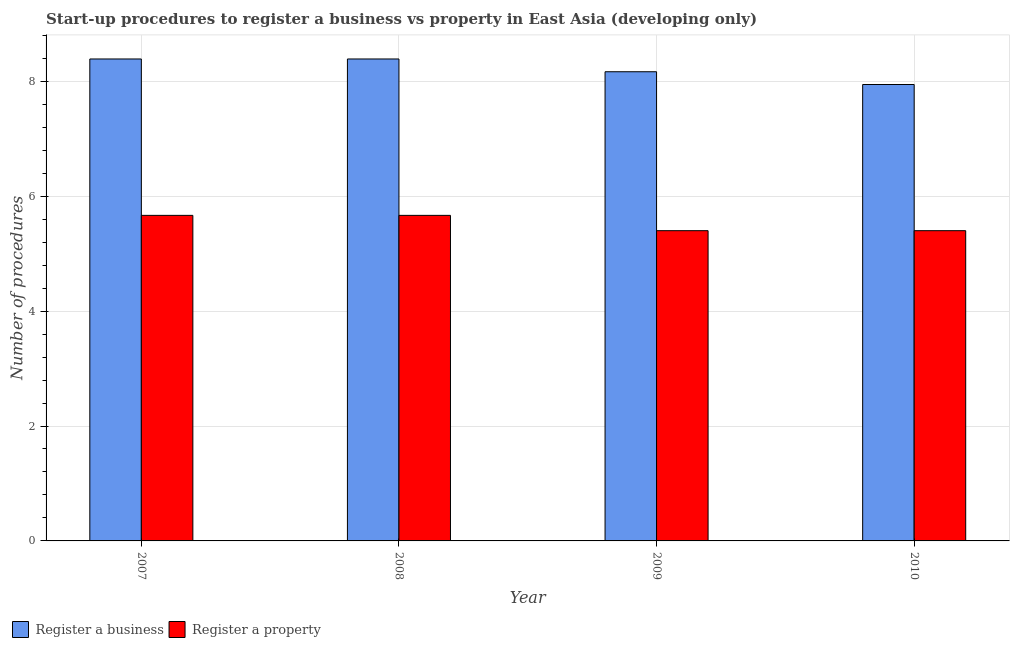How many groups of bars are there?
Your answer should be compact. 4. Are the number of bars per tick equal to the number of legend labels?
Ensure brevity in your answer.  Yes. What is the label of the 3rd group of bars from the left?
Your response must be concise. 2009. What is the number of procedures to register a business in 2008?
Your answer should be very brief. 8.39. Across all years, what is the maximum number of procedures to register a property?
Keep it short and to the point. 5.67. Across all years, what is the minimum number of procedures to register a property?
Make the answer very short. 5.4. In which year was the number of procedures to register a property maximum?
Your response must be concise. 2007. What is the total number of procedures to register a property in the graph?
Give a very brief answer. 22.13. What is the difference between the number of procedures to register a property in 2008 and that in 2010?
Ensure brevity in your answer.  0.27. What is the difference between the number of procedures to register a property in 2010 and the number of procedures to register a business in 2007?
Make the answer very short. -0.27. What is the average number of procedures to register a property per year?
Offer a terse response. 5.53. In the year 2009, what is the difference between the number of procedures to register a property and number of procedures to register a business?
Offer a very short reply. 0. In how many years, is the number of procedures to register a business greater than 0.4?
Give a very brief answer. 4. What is the ratio of the number of procedures to register a business in 2008 to that in 2009?
Offer a terse response. 1.03. What is the difference between the highest and the lowest number of procedures to register a property?
Offer a very short reply. 0.27. What does the 1st bar from the left in 2008 represents?
Offer a very short reply. Register a business. What does the 1st bar from the right in 2009 represents?
Your response must be concise. Register a property. How many bars are there?
Offer a terse response. 8. How many years are there in the graph?
Provide a succinct answer. 4. Does the graph contain any zero values?
Give a very brief answer. No. Does the graph contain grids?
Offer a terse response. Yes. Where does the legend appear in the graph?
Make the answer very short. Bottom left. How many legend labels are there?
Give a very brief answer. 2. What is the title of the graph?
Your answer should be compact. Start-up procedures to register a business vs property in East Asia (developing only). Does "Quality of trade" appear as one of the legend labels in the graph?
Keep it short and to the point. No. What is the label or title of the Y-axis?
Your answer should be compact. Number of procedures. What is the Number of procedures in Register a business in 2007?
Keep it short and to the point. 8.39. What is the Number of procedures in Register a property in 2007?
Keep it short and to the point. 5.67. What is the Number of procedures of Register a business in 2008?
Your answer should be compact. 8.39. What is the Number of procedures in Register a property in 2008?
Your response must be concise. 5.67. What is the Number of procedures in Register a business in 2009?
Keep it short and to the point. 8.17. What is the Number of procedures in Register a property in 2009?
Provide a short and direct response. 5.4. What is the Number of procedures of Register a business in 2010?
Offer a terse response. 7.94. Across all years, what is the maximum Number of procedures in Register a business?
Your answer should be very brief. 8.39. Across all years, what is the maximum Number of procedures in Register a property?
Your answer should be very brief. 5.67. Across all years, what is the minimum Number of procedures in Register a business?
Provide a short and direct response. 7.94. What is the total Number of procedures in Register a business in the graph?
Your answer should be compact. 32.89. What is the total Number of procedures in Register a property in the graph?
Offer a very short reply. 22.13. What is the difference between the Number of procedures of Register a business in 2007 and that in 2008?
Give a very brief answer. 0. What is the difference between the Number of procedures of Register a business in 2007 and that in 2009?
Give a very brief answer. 0.22. What is the difference between the Number of procedures in Register a property in 2007 and that in 2009?
Ensure brevity in your answer.  0.27. What is the difference between the Number of procedures in Register a business in 2007 and that in 2010?
Give a very brief answer. 0.44. What is the difference between the Number of procedures of Register a property in 2007 and that in 2010?
Ensure brevity in your answer.  0.27. What is the difference between the Number of procedures in Register a business in 2008 and that in 2009?
Provide a succinct answer. 0.22. What is the difference between the Number of procedures of Register a property in 2008 and that in 2009?
Keep it short and to the point. 0.27. What is the difference between the Number of procedures in Register a business in 2008 and that in 2010?
Provide a succinct answer. 0.44. What is the difference between the Number of procedures of Register a property in 2008 and that in 2010?
Offer a very short reply. 0.27. What is the difference between the Number of procedures in Register a business in 2009 and that in 2010?
Give a very brief answer. 0.22. What is the difference between the Number of procedures in Register a property in 2009 and that in 2010?
Make the answer very short. 0. What is the difference between the Number of procedures of Register a business in 2007 and the Number of procedures of Register a property in 2008?
Your answer should be compact. 2.72. What is the difference between the Number of procedures in Register a business in 2007 and the Number of procedures in Register a property in 2009?
Offer a very short reply. 2.99. What is the difference between the Number of procedures in Register a business in 2007 and the Number of procedures in Register a property in 2010?
Your answer should be compact. 2.99. What is the difference between the Number of procedures of Register a business in 2008 and the Number of procedures of Register a property in 2009?
Make the answer very short. 2.99. What is the difference between the Number of procedures in Register a business in 2008 and the Number of procedures in Register a property in 2010?
Give a very brief answer. 2.99. What is the difference between the Number of procedures of Register a business in 2009 and the Number of procedures of Register a property in 2010?
Keep it short and to the point. 2.77. What is the average Number of procedures of Register a business per year?
Offer a very short reply. 8.22. What is the average Number of procedures of Register a property per year?
Your answer should be very brief. 5.53. In the year 2007, what is the difference between the Number of procedures in Register a business and Number of procedures in Register a property?
Your response must be concise. 2.72. In the year 2008, what is the difference between the Number of procedures of Register a business and Number of procedures of Register a property?
Your answer should be compact. 2.72. In the year 2009, what is the difference between the Number of procedures in Register a business and Number of procedures in Register a property?
Your response must be concise. 2.77. In the year 2010, what is the difference between the Number of procedures of Register a business and Number of procedures of Register a property?
Give a very brief answer. 2.54. What is the ratio of the Number of procedures in Register a business in 2007 to that in 2009?
Your answer should be compact. 1.03. What is the ratio of the Number of procedures of Register a property in 2007 to that in 2009?
Make the answer very short. 1.05. What is the ratio of the Number of procedures of Register a business in 2007 to that in 2010?
Provide a short and direct response. 1.06. What is the ratio of the Number of procedures of Register a property in 2007 to that in 2010?
Keep it short and to the point. 1.05. What is the ratio of the Number of procedures in Register a business in 2008 to that in 2009?
Ensure brevity in your answer.  1.03. What is the ratio of the Number of procedures in Register a property in 2008 to that in 2009?
Your answer should be compact. 1.05. What is the ratio of the Number of procedures of Register a business in 2008 to that in 2010?
Ensure brevity in your answer.  1.06. What is the ratio of the Number of procedures in Register a property in 2008 to that in 2010?
Give a very brief answer. 1.05. What is the ratio of the Number of procedures in Register a business in 2009 to that in 2010?
Give a very brief answer. 1.03. What is the difference between the highest and the second highest Number of procedures in Register a business?
Your response must be concise. 0. What is the difference between the highest and the lowest Number of procedures of Register a business?
Make the answer very short. 0.44. What is the difference between the highest and the lowest Number of procedures in Register a property?
Provide a succinct answer. 0.27. 